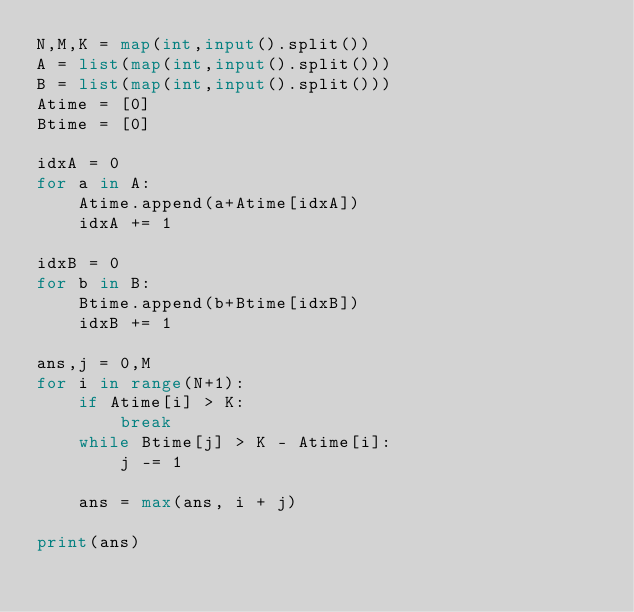<code> <loc_0><loc_0><loc_500><loc_500><_Python_>N,M,K = map(int,input().split())
A = list(map(int,input().split()))
B = list(map(int,input().split()))
Atime = [0]
Btime = [0]

idxA = 0
for a in A:
    Atime.append(a+Atime[idxA])
    idxA += 1

idxB = 0
for b in B:
    Btime.append(b+Btime[idxB])
    idxB += 1

ans,j = 0,M
for i in range(N+1):
    if Atime[i] > K:
        break
    while Btime[j] > K - Atime[i]:
        j -= 1
    
    ans = max(ans, i + j)

print(ans)</code> 